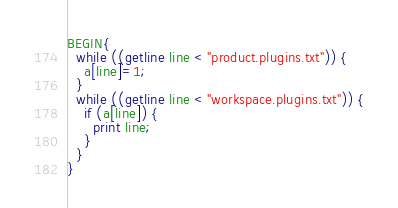<code> <loc_0><loc_0><loc_500><loc_500><_Awk_>BEGIN{
  while ((getline line < "product.plugins.txt")) {
    a[line]=1;
  }
  while ((getline line < "workspace.plugins.txt")) {
    if (a[line]) {
      print line;
    }
  }
}
</code> 